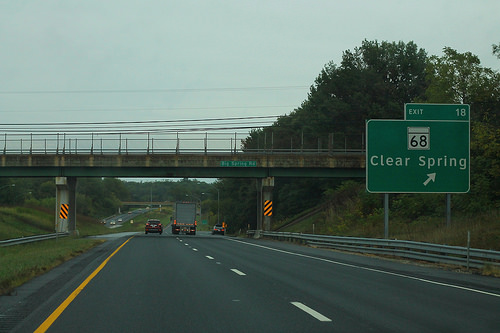<image>
Is there a sign under the bridge? No. The sign is not positioned under the bridge. The vertical relationship between these objects is different. Is the sky behind the board? Yes. From this viewpoint, the sky is positioned behind the board, with the board partially or fully occluding the sky. 